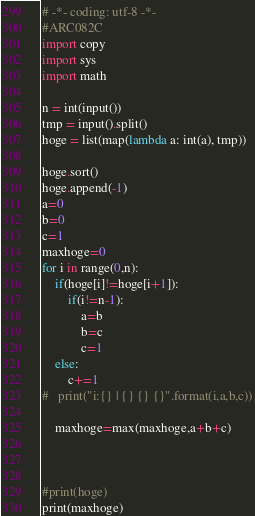Convert code to text. <code><loc_0><loc_0><loc_500><loc_500><_Python_># -*- coding: utf-8 -*-
#ARC082C
import copy
import sys
import math

n = int(input())
tmp = input().split()
hoge = list(map(lambda a: int(a), tmp))

hoge.sort()
hoge.append(-1)
a=0
b=0
c=1
maxhoge=0
for i in range(0,n):
	if(hoge[i]!=hoge[i+1]):
		if(i!=n-1):
			a=b
			b=c
			c=1
	else:
		c+=1
#	print("i:{} | {} {} {}".format(i,a,b,c))

	maxhoge=max(maxhoge,a+b+c)



#print(hoge)
print(maxhoge)

</code> 